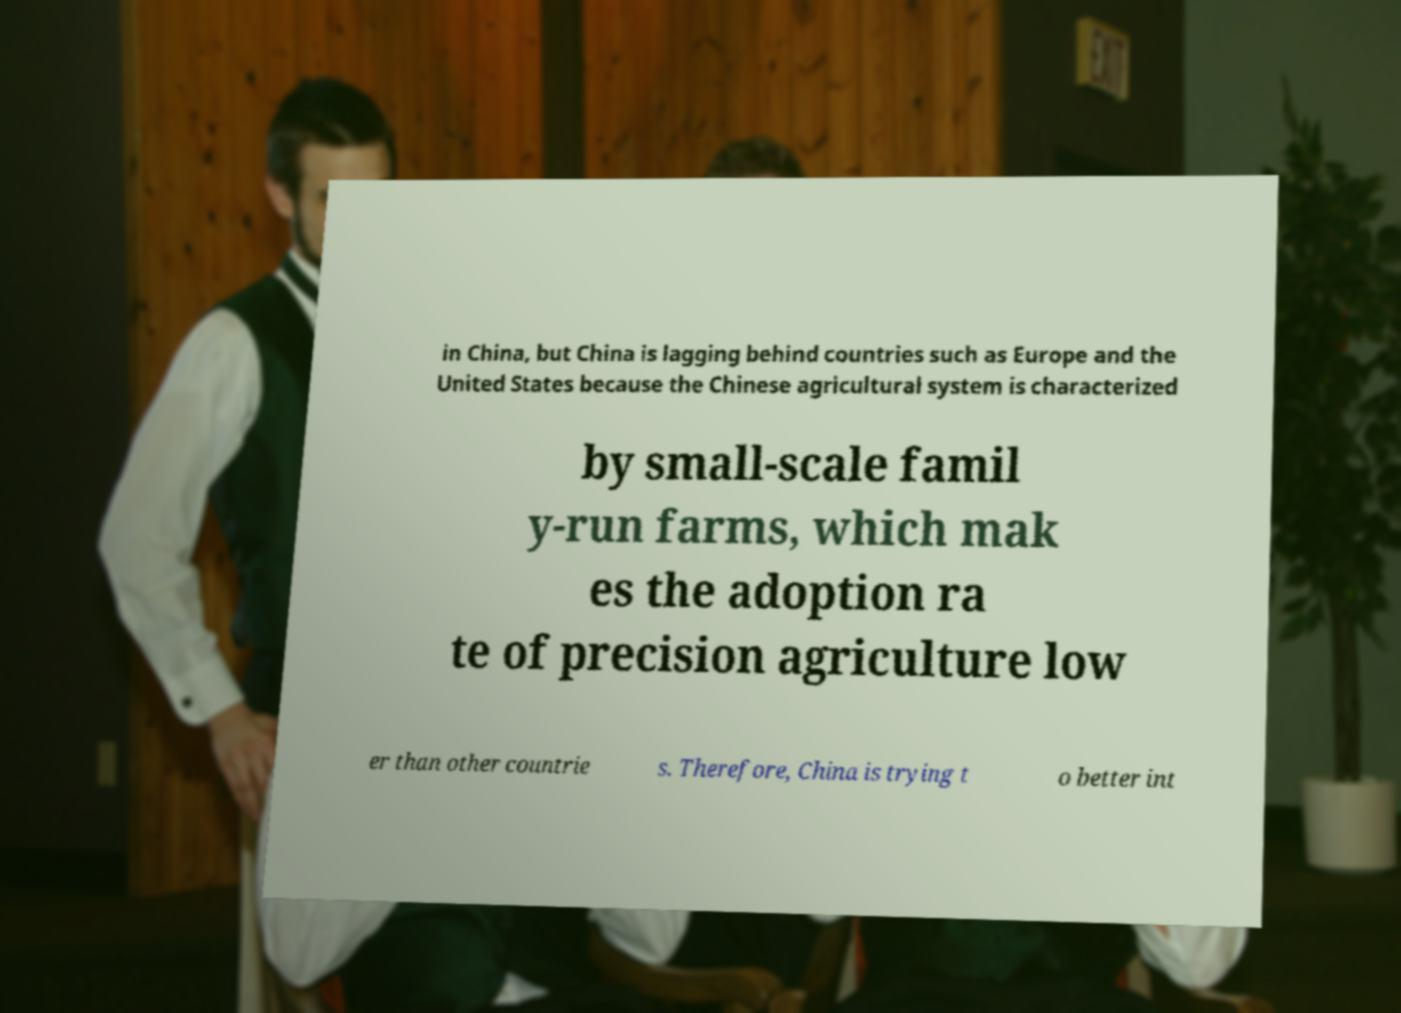Can you read and provide the text displayed in the image?This photo seems to have some interesting text. Can you extract and type it out for me? in China, but China is lagging behind countries such as Europe and the United States because the Chinese agricultural system is characterized by small-scale famil y-run farms, which mak es the adoption ra te of precision agriculture low er than other countrie s. Therefore, China is trying t o better int 